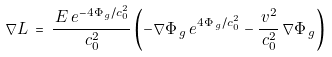Convert formula to latex. <formula><loc_0><loc_0><loc_500><loc_500>\nabla L \, = \, \frac { \, E \, e ^ { - 4 \Phi _ { \, g } / c _ { 0 } ^ { 2 } } } { \, c _ { 0 } ^ { 2 } } \left ( - \nabla \Phi _ { \, g } \, e ^ { 4 \Phi _ { \, g } / c _ { 0 } ^ { 2 } } - \frac { \, v ^ { 2 } } { \, c _ { 0 } ^ { 2 } } \, \nabla \Phi _ { \, g } \right )</formula> 